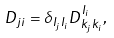<formula> <loc_0><loc_0><loc_500><loc_500>D _ { j i } = \delta _ { I _ { j } I _ { i } } D ^ { I _ { i } } _ { k _ { j } k _ { i } } ,</formula> 